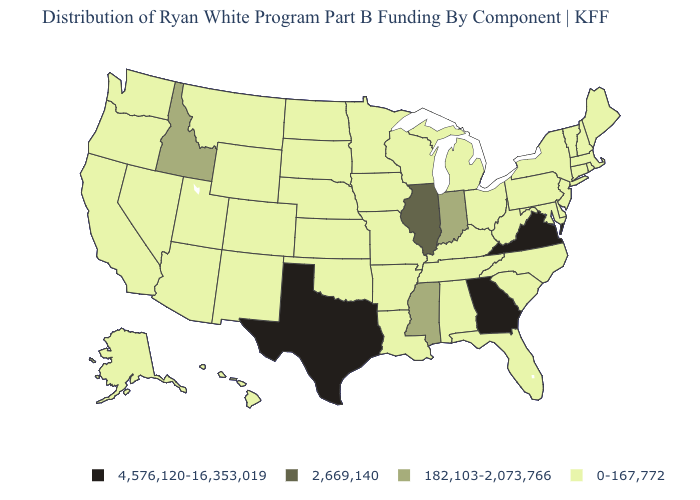What is the highest value in the USA?
Be succinct. 4,576,120-16,353,019. What is the lowest value in the MidWest?
Give a very brief answer. 0-167,772. What is the highest value in states that border New Jersey?
Answer briefly. 0-167,772. Name the states that have a value in the range 2,669,140?
Short answer required. Illinois. Does the map have missing data?
Write a very short answer. No. Does Missouri have the lowest value in the USA?
Keep it brief. Yes. What is the value of Florida?
Short answer required. 0-167,772. Name the states that have a value in the range 0-167,772?
Give a very brief answer. Alabama, Alaska, Arizona, Arkansas, California, Colorado, Connecticut, Delaware, Florida, Hawaii, Iowa, Kansas, Kentucky, Louisiana, Maine, Maryland, Massachusetts, Michigan, Minnesota, Missouri, Montana, Nebraska, Nevada, New Hampshire, New Jersey, New Mexico, New York, North Carolina, North Dakota, Ohio, Oklahoma, Oregon, Pennsylvania, Rhode Island, South Carolina, South Dakota, Tennessee, Utah, Vermont, Washington, West Virginia, Wisconsin, Wyoming. What is the value of Delaware?
Answer briefly. 0-167,772. Name the states that have a value in the range 4,576,120-16,353,019?
Short answer required. Georgia, Texas, Virginia. Name the states that have a value in the range 182,103-2,073,766?
Short answer required. Idaho, Indiana, Mississippi. What is the lowest value in the USA?
Keep it brief. 0-167,772. Does Illinois have the highest value in the MidWest?
Give a very brief answer. Yes. Name the states that have a value in the range 2,669,140?
Give a very brief answer. Illinois. How many symbols are there in the legend?
Quick response, please. 4. 